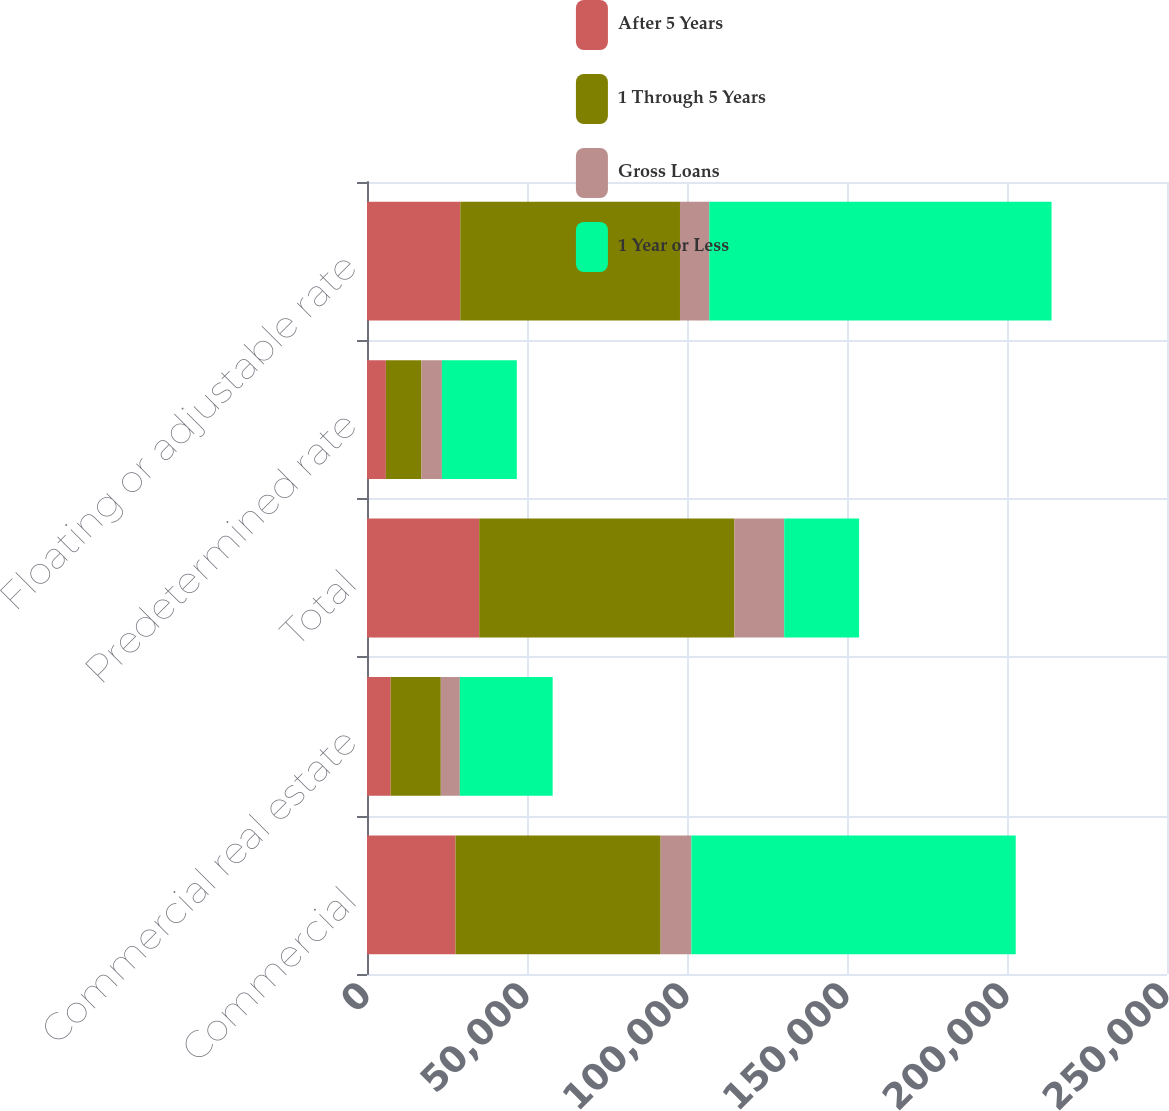Convert chart to OTSL. <chart><loc_0><loc_0><loc_500><loc_500><stacked_bar_chart><ecel><fcel>Commercial<fcel>Commercial real estate<fcel>Total<fcel>Predetermined rate<fcel>Floating or adjustable rate<nl><fcel>After 5 Years<fcel>27656<fcel>7404<fcel>35060<fcel>5902<fcel>29158<nl><fcel>1 Through 5 Years<fcel>64109<fcel>15658<fcel>79767<fcel>11116<fcel>68651<nl><fcel>Gross Loans<fcel>9599<fcel>5948<fcel>15547<fcel>6392<fcel>9155<nl><fcel>1 Year or Less<fcel>101364<fcel>29010<fcel>23410<fcel>23410<fcel>106964<nl></chart> 